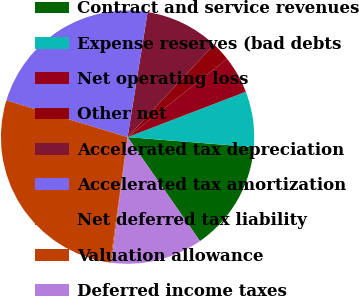Convert chart to OTSL. <chart><loc_0><loc_0><loc_500><loc_500><pie_chart><fcel>Contract and service revenues<fcel>Expense reserves (bad debts<fcel>Net operating loss<fcel>Other net<fcel>Accelerated tax depreciation<fcel>Accelerated tax amortization<fcel>Net deferred tax liability<fcel>Valuation allowance<fcel>Deferred income taxes<nl><fcel>14.06%<fcel>7.09%<fcel>4.77%<fcel>2.45%<fcel>9.42%<fcel>22.85%<fcel>27.49%<fcel>0.13%<fcel>11.74%<nl></chart> 